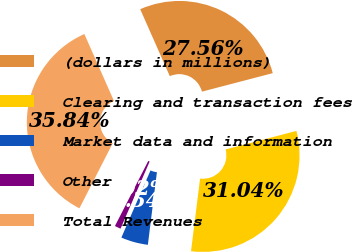Convert chart. <chart><loc_0><loc_0><loc_500><loc_500><pie_chart><fcel>(dollars in millions)<fcel>Clearing and transaction fees<fcel>Market data and information<fcel>Other<fcel>Total Revenues<nl><fcel>27.56%<fcel>31.04%<fcel>4.54%<fcel>1.02%<fcel>35.84%<nl></chart> 